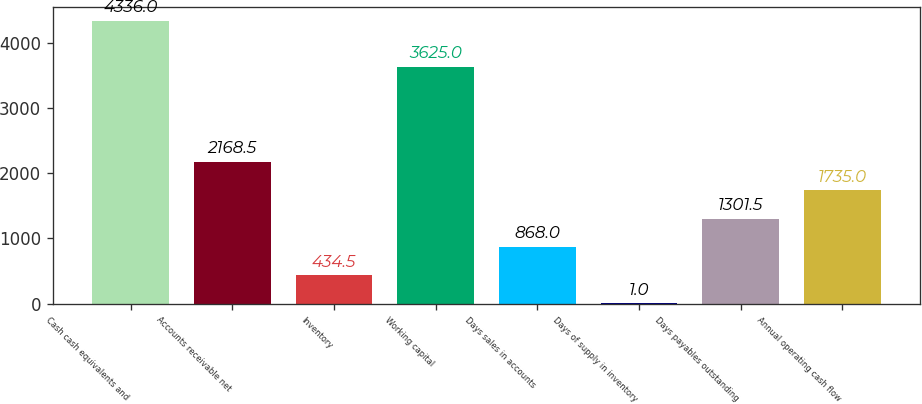Convert chart to OTSL. <chart><loc_0><loc_0><loc_500><loc_500><bar_chart><fcel>Cash cash equivalents and<fcel>Accounts receivable net<fcel>Inventory<fcel>Working capital<fcel>Days sales in accounts<fcel>Days of supply in inventory<fcel>Days payables outstanding<fcel>Annual operating cash flow<nl><fcel>4336<fcel>2168.5<fcel>434.5<fcel>3625<fcel>868<fcel>1<fcel>1301.5<fcel>1735<nl></chart> 